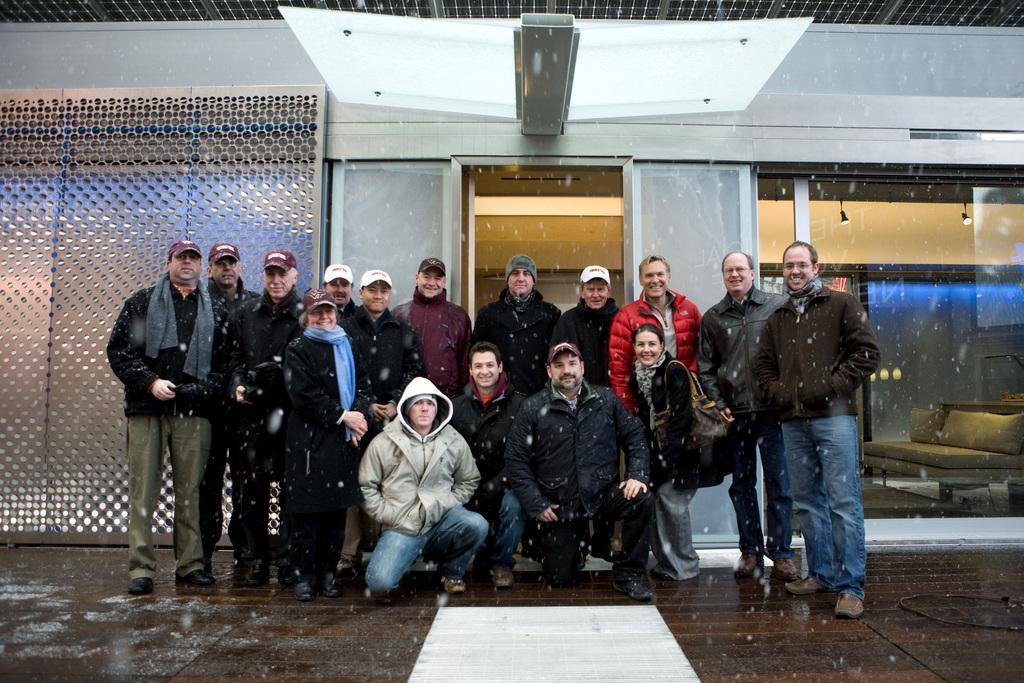Can you describe this image briefly? In this picture we can people giving a pose. Through glass we can see lights and a sofa. On the left side of the picture we can see the wall. At the bottom we can see the floor. 